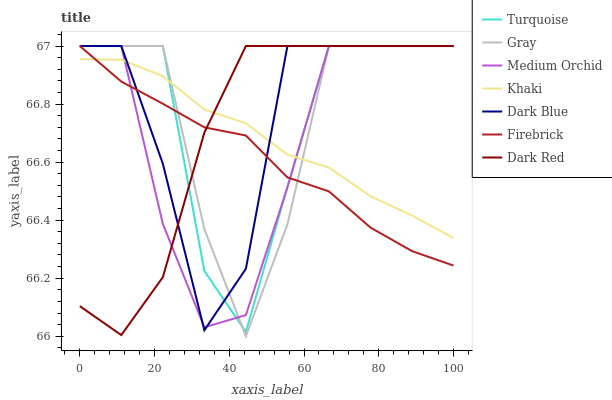Does Firebrick have the minimum area under the curve?
Answer yes or no. Yes. Does Dark Blue have the maximum area under the curve?
Answer yes or no. Yes. Does Turquoise have the minimum area under the curve?
Answer yes or no. No. Does Turquoise have the maximum area under the curve?
Answer yes or no. No. Is Khaki the smoothest?
Answer yes or no. Yes. Is Dark Blue the roughest?
Answer yes or no. Yes. Is Turquoise the smoothest?
Answer yes or no. No. Is Turquoise the roughest?
Answer yes or no. No. Does Gray have the lowest value?
Answer yes or no. Yes. Does Turquoise have the lowest value?
Answer yes or no. No. Does Dark Blue have the highest value?
Answer yes or no. Yes. Does Khaki have the highest value?
Answer yes or no. No. Does Firebrick intersect Medium Orchid?
Answer yes or no. Yes. Is Firebrick less than Medium Orchid?
Answer yes or no. No. Is Firebrick greater than Medium Orchid?
Answer yes or no. No. 